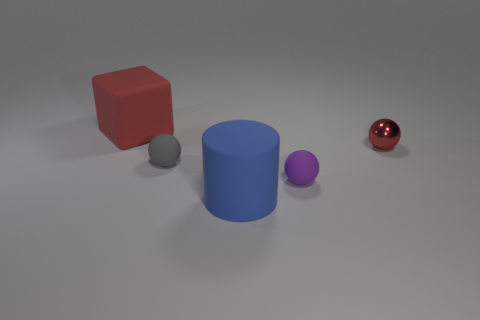Do the blue rubber cylinder and the block have the same size?
Make the answer very short. Yes. What is the size of the blue rubber cylinder?
Offer a terse response. Large. How big is the red object that is right of the tiny gray matte ball?
Provide a succinct answer. Small. What shape is the big object that is made of the same material as the block?
Provide a short and direct response. Cylinder. Are the ball to the left of the blue cylinder and the big red block made of the same material?
Offer a very short reply. Yes. How many other things are the same material as the tiny purple thing?
Your response must be concise. 3. What number of objects are small matte balls that are in front of the gray matte object or things on the right side of the red rubber thing?
Offer a terse response. 4. Does the red thing right of the blue rubber cylinder have the same shape as the gray thing left of the big blue cylinder?
Your response must be concise. Yes. There is a purple matte object that is the same size as the gray ball; what is its shape?
Your answer should be compact. Sphere. What number of metallic things are big blocks or big brown cubes?
Offer a very short reply. 0. 